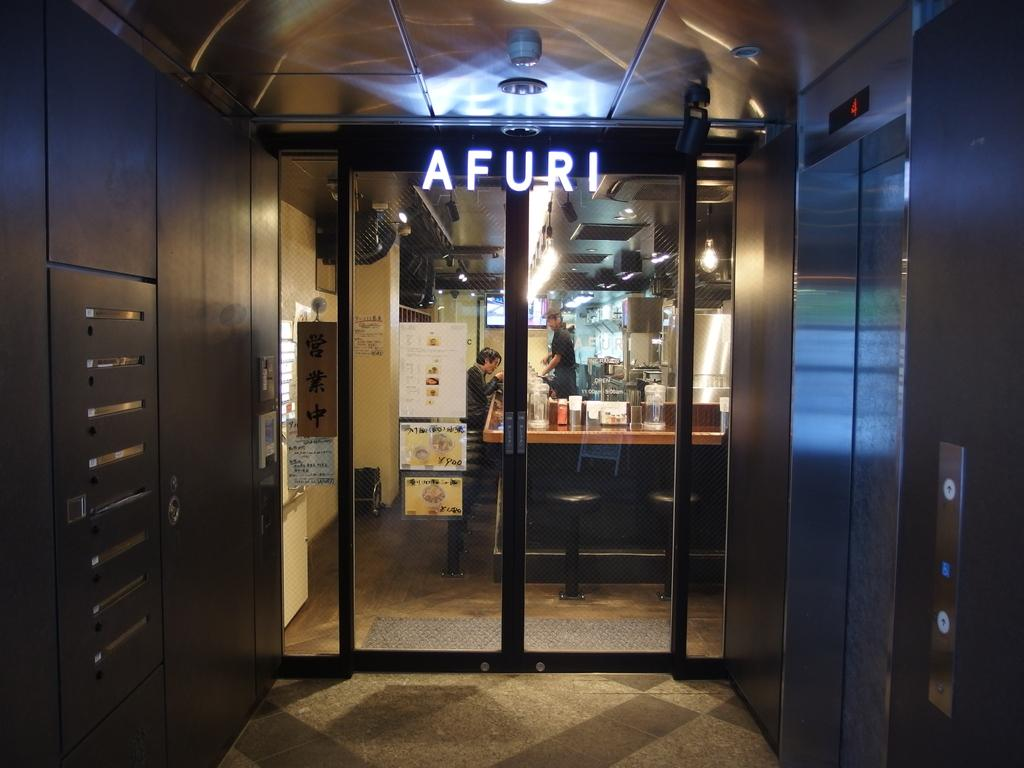Provide a one-sentence caption for the provided image. Afuri sign in big letters on a front door. 